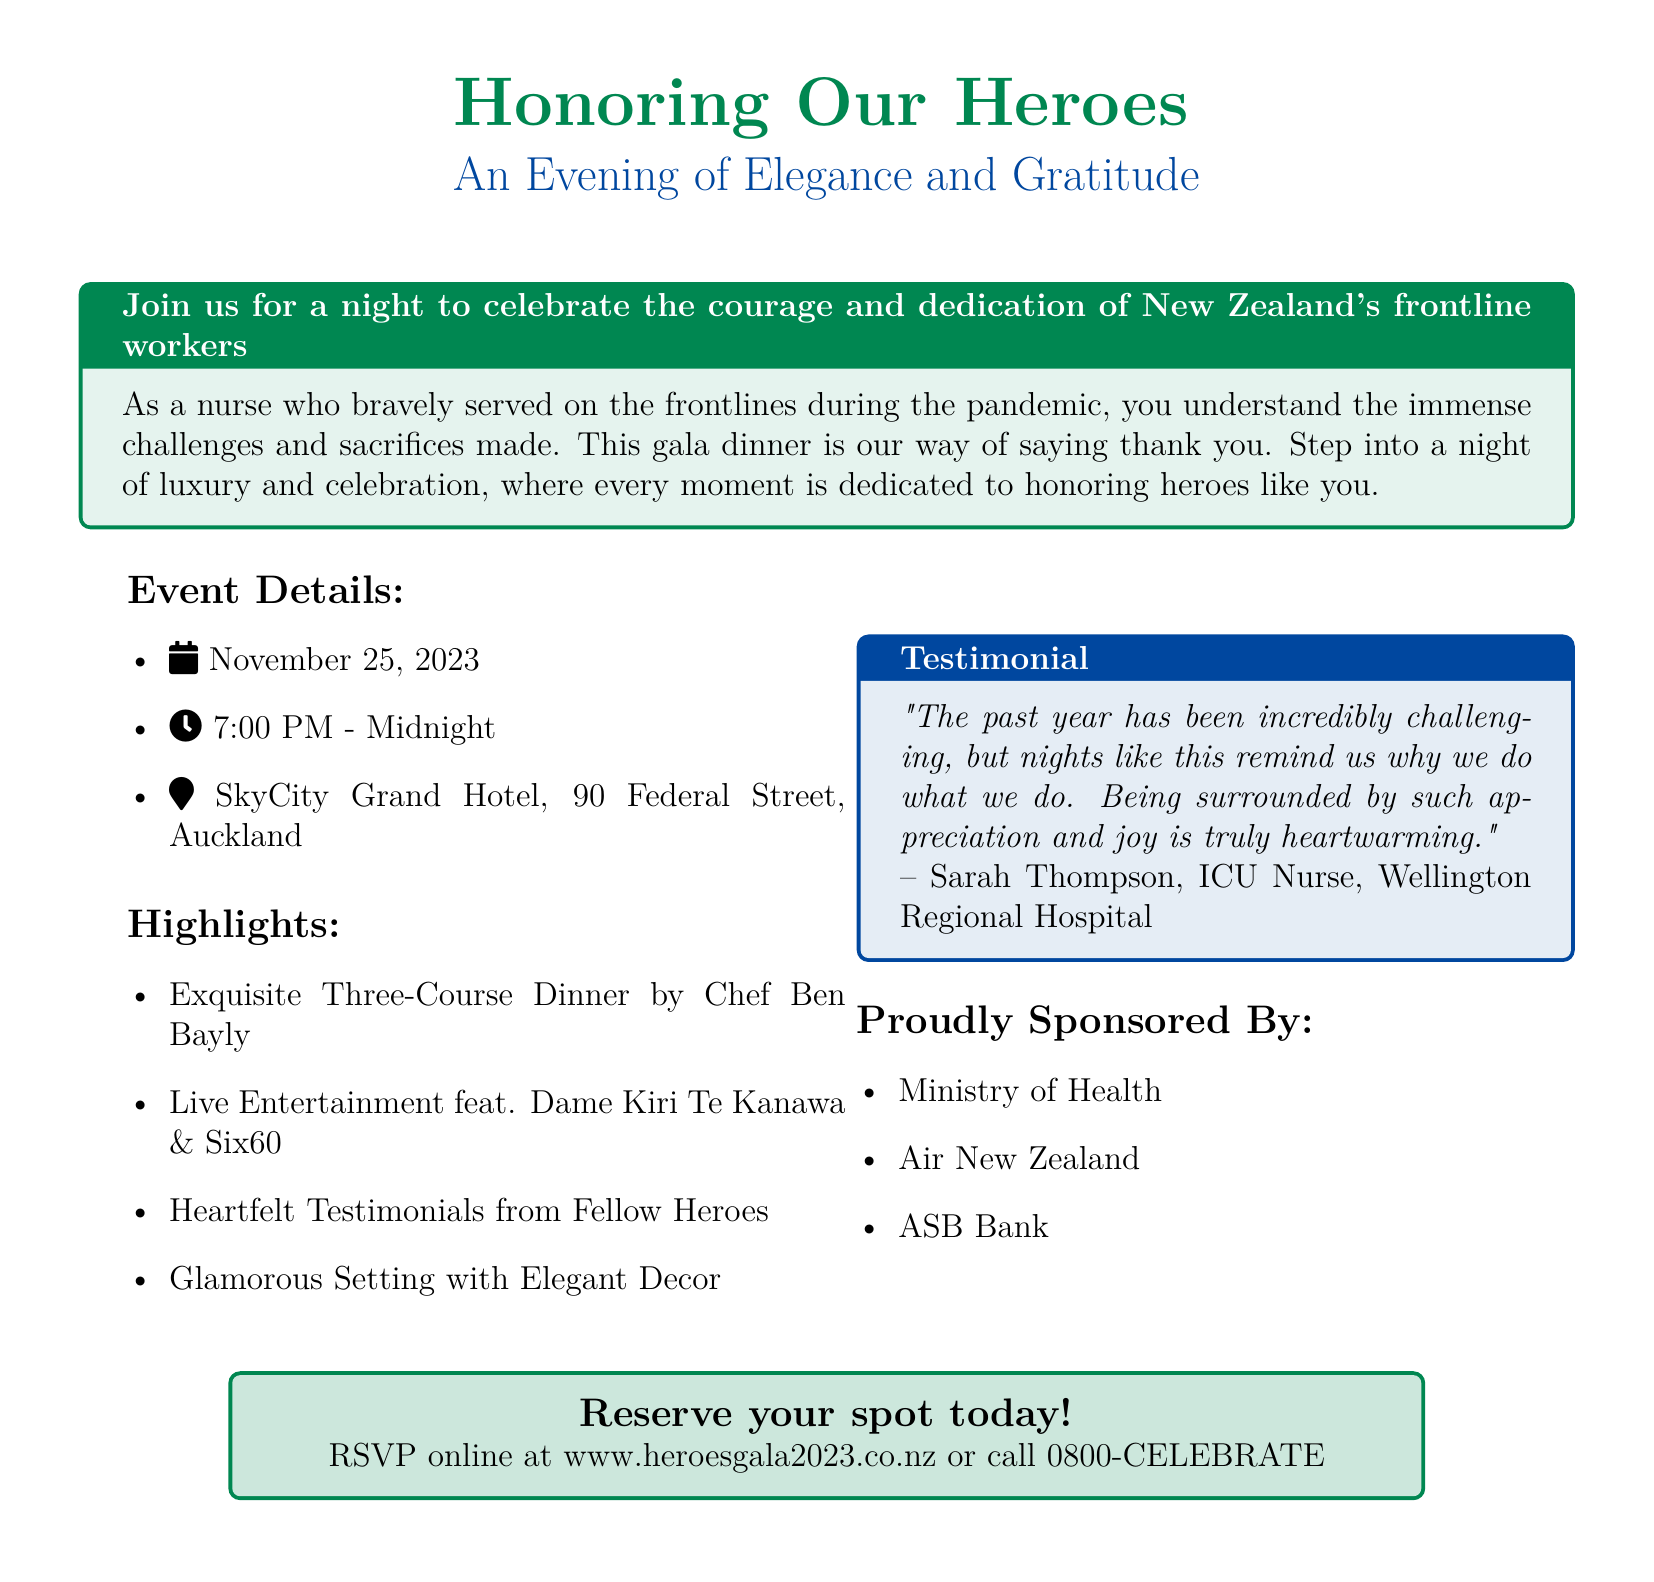what is the date of the event? The event date is explicitly stated in the document as November 25, 2023.
Answer: November 25, 2023 what time does the gala start? The starting time of the gala is provided in the event details as 7:00 PM.
Answer: 7:00 PM where is the event being held? The location is specified in the document as SkyCity Grand Hotel, 90 Federal Street, Auckland.
Answer: SkyCity Grand Hotel, 90 Federal Street, Auckland who are the featured entertainers? The document mentions Dame Kiri Te Kanawa and Six60 as live entertainment performers at the gala.
Answer: Dame Kiri Te Kanawa & Six60 what type of dinner will be served at the gala? The advertisement states that there will be an exquisite three-course dinner prepared by Chef Ben Bayly.
Answer: Three-Course Dinner what is the purpose of the event? The purpose is highlighted as a celebration of the courage and dedication of New Zealand's frontline workers.
Answer: Celebrating frontline workers who provided a testimonial in the advertisement? The testimonial is provided by Sarah Thompson, an ICU nurse at Wellington Regional Hospital.
Answer: Sarah Thompson which organizations sponsored the event? The sponsors listed in the document include the Ministry of Health, Air New Zealand, and ASB Bank.
Answer: Ministry of Health, Air New Zealand, ASB Bank how can attendees reserve their spots? The document instructs attendees to RSVP online or call a specific number to reserve their spots.
Answer: RSVP online at www.heroesgala2023.co.nz or call 0800-CELEBRATE 